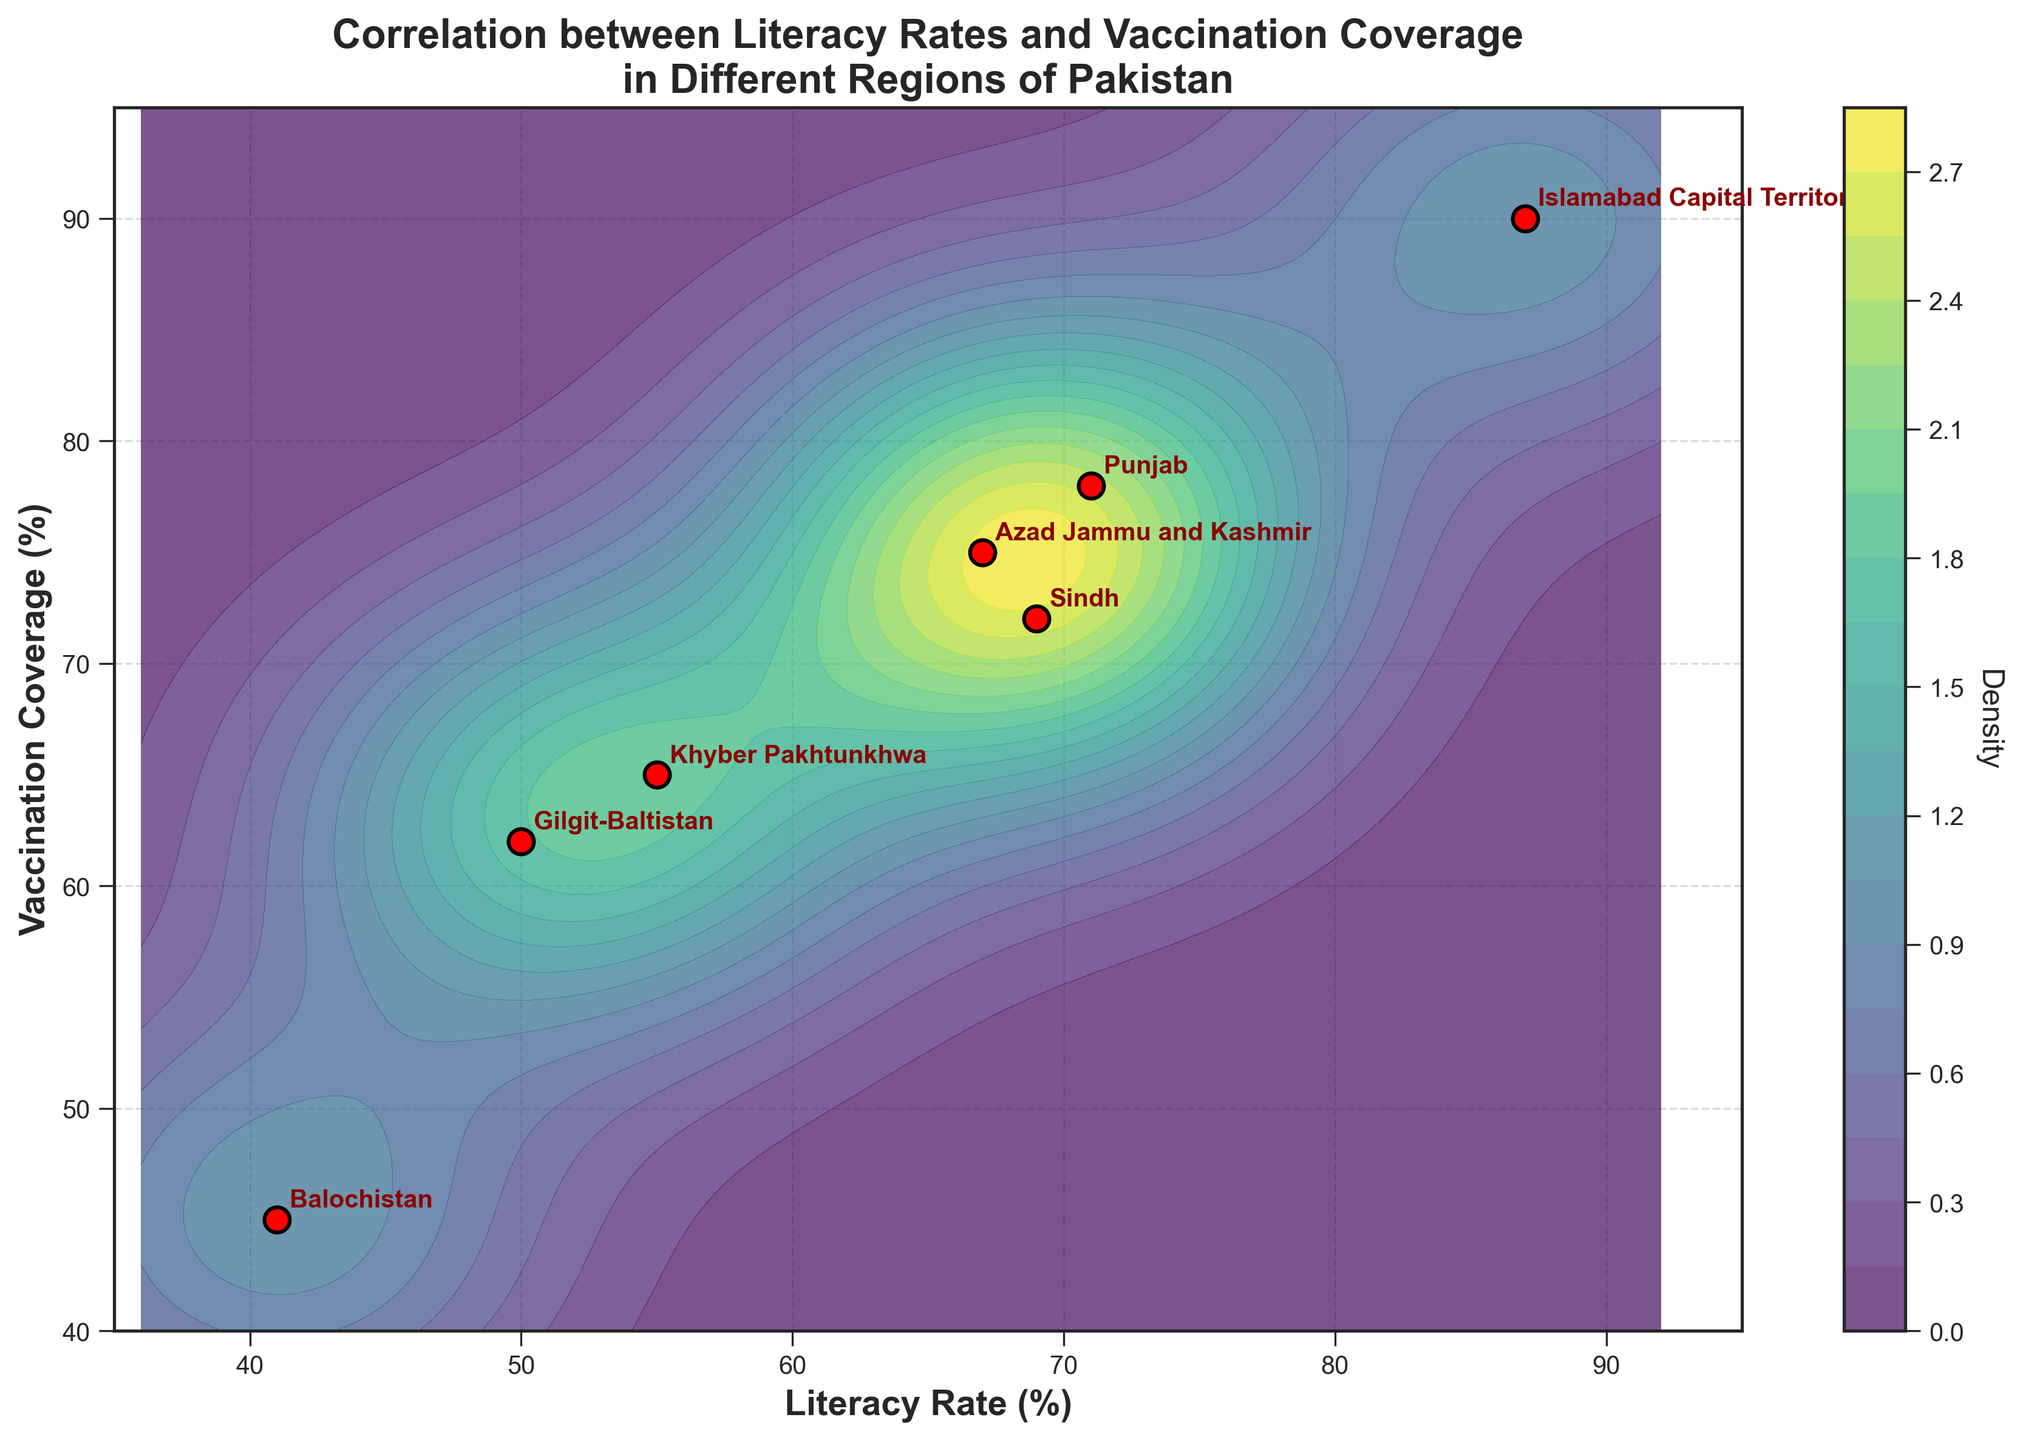What is the title of the figure? The title is usually found at the top of the figure. It summarizes the main topic or data analysis being represented.
Answer: Correlation between Literacy Rates and Vaccination Coverage in Different Regions of Pakistan What are the variables plotted on the x and y axes? The x-axis and y-axis labels indicate what is being measured or compared in the plot. The x-axis label shows "Literacy Rate (%)", and the y-axis label shows "Vaccination Coverage (%)".
Answer: Literacy Rate (%) and Vaccination Coverage (%) How many regions in Pakistan are represented in the plot? There are data points marked with red dots, each representing a different region of Pakistan. Counting these dots gives the total number of regions.
Answer: 7 Which region has the highest vaccination coverage? To find the region with the highest vaccination coverage, locate the data point with the highest y-value and check the associated label.
Answer: Islamabad Capital Territory Which region has the lowest literacy rate? To identify the region with the lowest literacy rate, look for the data point with the lowest x-value and see the corresponding label.
Answer: Balochistan Is there a positive correlation between literacy rate and vaccination coverage? Positive correlation means that as one variable increases, the other variable also increases. Inspecting the scatter points and the contour levels would show if there is a trend where higher literacy rates are associated with higher vaccination coverage.
Answer: Yes Compare the literacy rates of Punjab and Sindh. Which region has a higher literacy rate? Locate the data points for Punjab and Sindh, and compare the x-values. Punjab has a literacy rate of 71%, and Sindh has a literacy rate of 69%.
Answer: Punjab How does the vaccination coverage in Khyber Pakhtunkhwa compare to that in Azad Jammu and Kashmir? Locate the data points for Khyber Pakhtunkhwa and Azad Jammu and Kashmir, and compare the y-values. Khyber Pakhtunkhwa has a vaccination coverage of 65%, while Azad Jammu and Kashmir have 75%.
Answer: Lower by 10% Which two regions have the closest literacy rates? To find the regions with the closest literacy rates, compare the x-values of each region to find the pair with the smallest difference.
Answer: Punjab and Sindh Explain the contour levels in the plot. Contour levels represent the density of the data points in the space created by the literacy rate and vaccination coverage. Darker areas indicate higher density, meaning more data points are close together in those areas.
Answer: Density of data points 